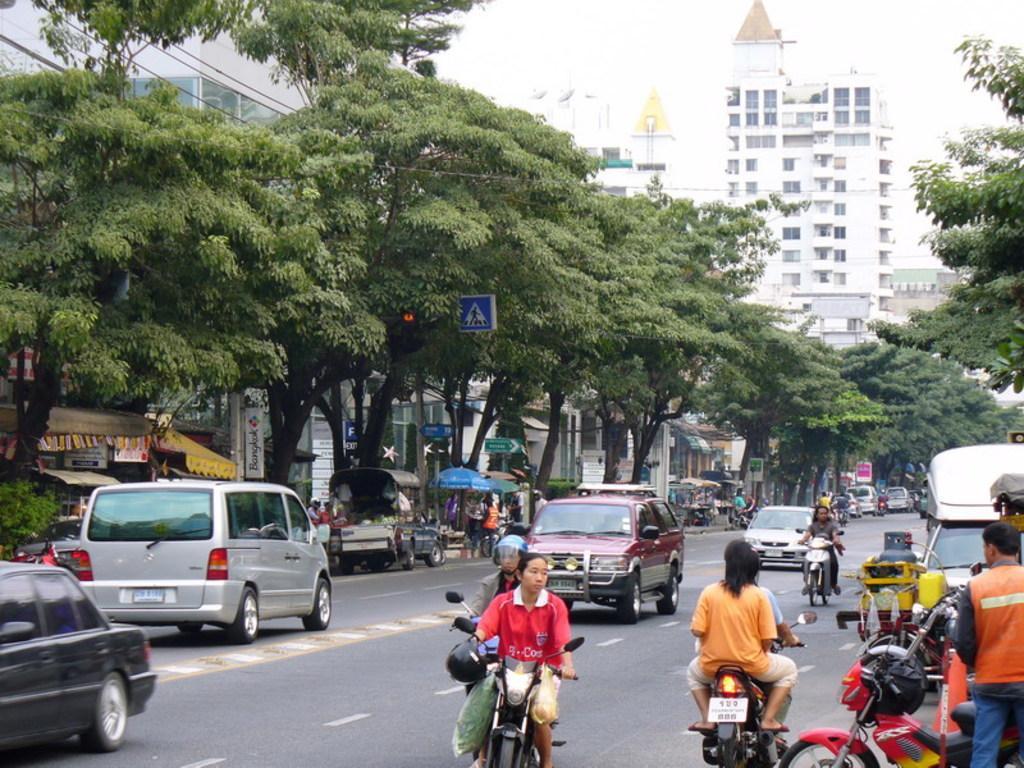How would you summarize this image in a sentence or two? In this image there is a road in bottom of this image and there are some vehicles on the road as we can see in the bottom of this image. There are some trees in middle of this image, and there are some buildings in the background. There is a sky on the top of this image. 